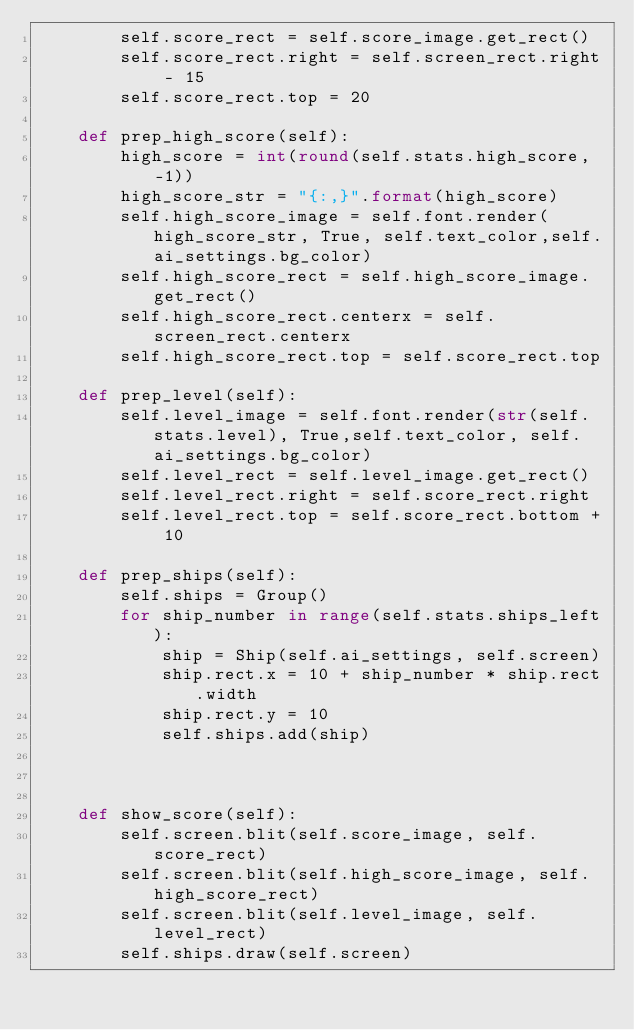<code> <loc_0><loc_0><loc_500><loc_500><_Python_>        self.score_rect = self.score_image.get_rect()
        self.score_rect.right = self.screen_rect.right - 15
        self.score_rect.top = 20

    def prep_high_score(self):
        high_score = int(round(self.stats.high_score, -1))
        high_score_str = "{:,}".format(high_score)
        self.high_score_image = self.font.render(high_score_str, True, self.text_color,self.ai_settings.bg_color)
        self.high_score_rect = self.high_score_image.get_rect()
        self.high_score_rect.centerx = self.screen_rect.centerx
        self.high_score_rect.top = self.score_rect.top

    def prep_level(self):
        self.level_image = self.font.render(str(self.stats.level), True,self.text_color, self.ai_settings.bg_color)
        self.level_rect = self.level_image.get_rect()
        self.level_rect.right = self.score_rect.right
        self.level_rect.top = self.score_rect.bottom + 10

    def prep_ships(self):
        self.ships = Group()
        for ship_number in range(self.stats.ships_left):
            ship = Ship(self.ai_settings, self.screen)
            ship.rect.x = 10 + ship_number * ship.rect.width
            ship.rect.y = 10
            self.ships.add(ship)



    def show_score(self):
        self.screen.blit(self.score_image, self.score_rect)
        self.screen.blit(self.high_score_image, self.high_score_rect)
        self.screen.blit(self.level_image, self.level_rect)
        self.ships.draw(self.screen)</code> 